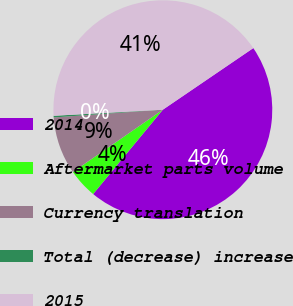<chart> <loc_0><loc_0><loc_500><loc_500><pie_chart><fcel>2014<fcel>Aftermarket parts volume<fcel>Currency translation<fcel>Total (decrease) increase<fcel>2015<nl><fcel>45.51%<fcel>4.37%<fcel>8.51%<fcel>0.24%<fcel>41.37%<nl></chart> 